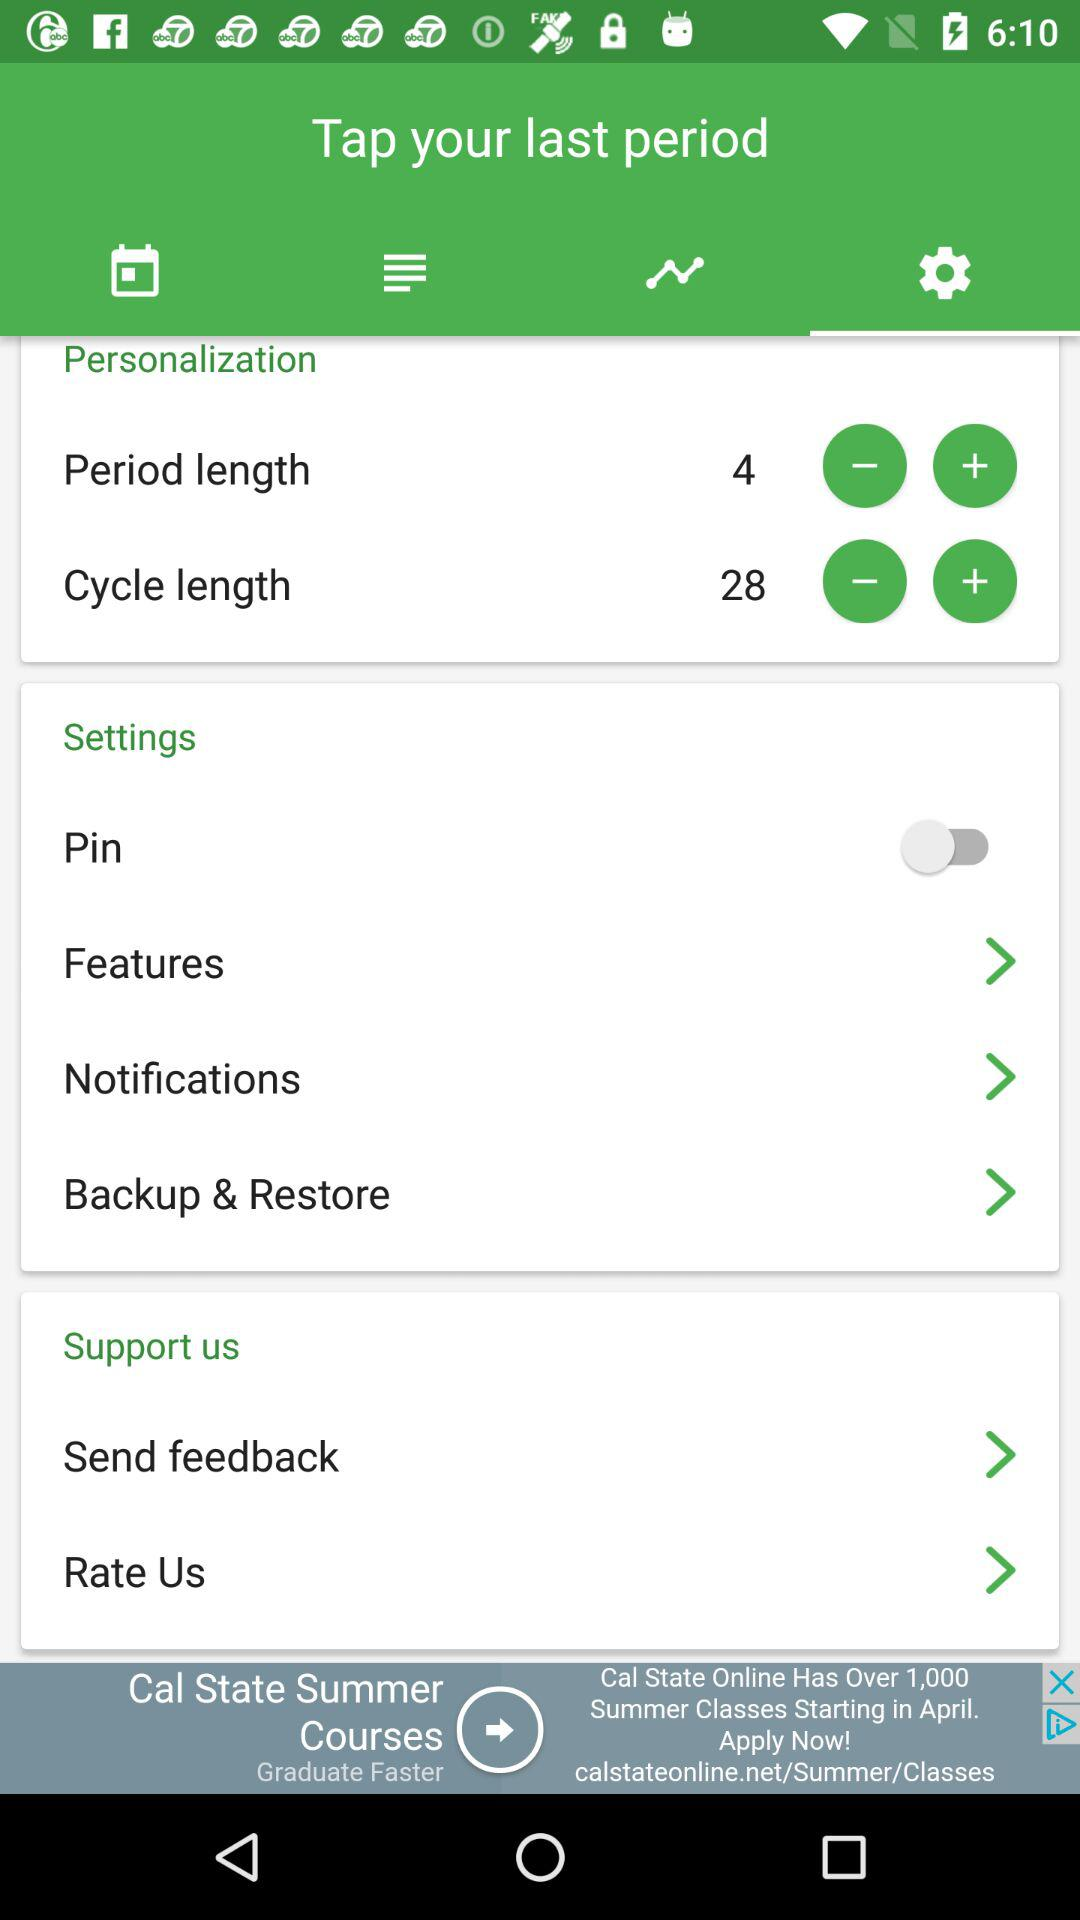How many items have a plus sign next to them?
Answer the question using a single word or phrase. 2 